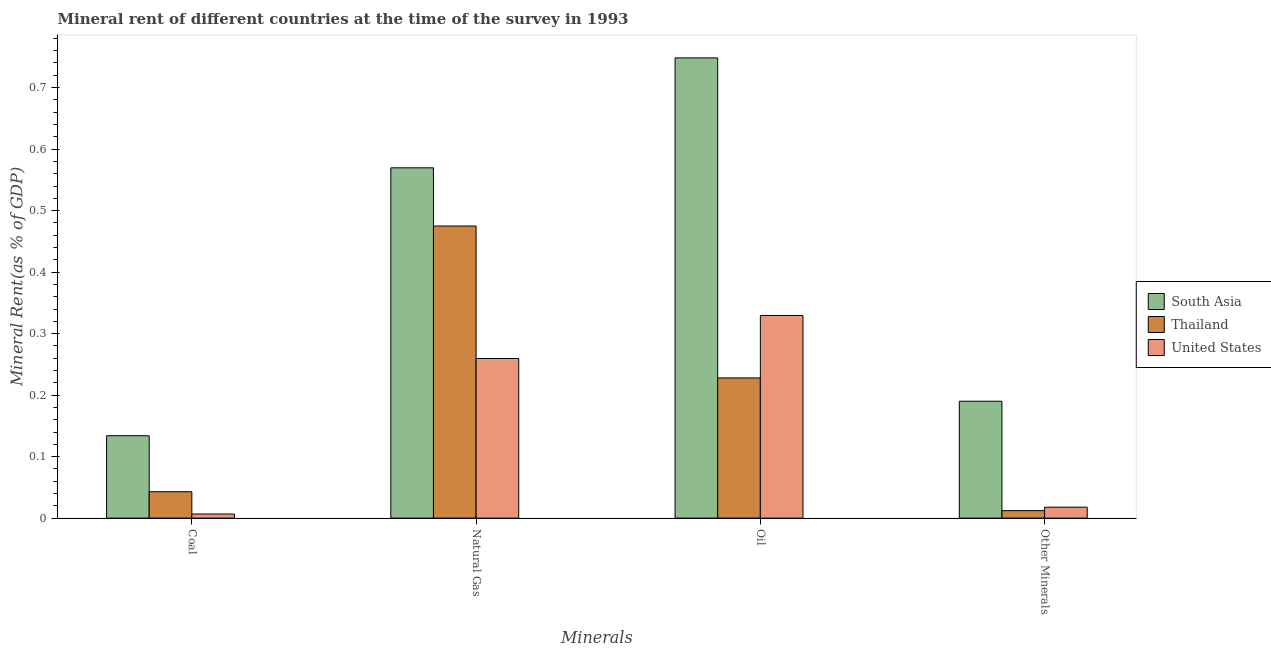How many groups of bars are there?
Your response must be concise. 4. Are the number of bars on each tick of the X-axis equal?
Your response must be concise. Yes. How many bars are there on the 2nd tick from the left?
Your answer should be very brief. 3. What is the label of the 2nd group of bars from the left?
Keep it short and to the point. Natural Gas. What is the coal rent in South Asia?
Offer a very short reply. 0.13. Across all countries, what is the maximum natural gas rent?
Your answer should be very brief. 0.57. Across all countries, what is the minimum oil rent?
Your response must be concise. 0.23. In which country was the coal rent maximum?
Provide a succinct answer. South Asia. In which country was the  rent of other minerals minimum?
Provide a succinct answer. Thailand. What is the total  rent of other minerals in the graph?
Ensure brevity in your answer.  0.22. What is the difference between the coal rent in United States and that in Thailand?
Provide a succinct answer. -0.04. What is the difference between the oil rent in United States and the natural gas rent in South Asia?
Your answer should be very brief. -0.24. What is the average oil rent per country?
Your answer should be compact. 0.44. What is the difference between the  rent of other minerals and natural gas rent in South Asia?
Provide a short and direct response. -0.38. In how many countries, is the natural gas rent greater than 0.1 %?
Provide a short and direct response. 3. What is the ratio of the coal rent in United States to that in Thailand?
Your answer should be very brief. 0.16. What is the difference between the highest and the second highest natural gas rent?
Your answer should be very brief. 0.09. What is the difference between the highest and the lowest  rent of other minerals?
Your answer should be compact. 0.18. Is the sum of the  rent of other minerals in Thailand and United States greater than the maximum oil rent across all countries?
Your response must be concise. No. Is it the case that in every country, the sum of the  rent of other minerals and coal rent is greater than the sum of natural gas rent and oil rent?
Give a very brief answer. No. What does the 1st bar from the left in Oil represents?
Your response must be concise. South Asia. What does the 2nd bar from the right in Natural Gas represents?
Offer a very short reply. Thailand. Is it the case that in every country, the sum of the coal rent and natural gas rent is greater than the oil rent?
Provide a succinct answer. No. How many bars are there?
Your answer should be compact. 12. Are all the bars in the graph horizontal?
Make the answer very short. No. What is the difference between two consecutive major ticks on the Y-axis?
Your response must be concise. 0.1. Are the values on the major ticks of Y-axis written in scientific E-notation?
Provide a succinct answer. No. Does the graph contain any zero values?
Provide a succinct answer. No. Where does the legend appear in the graph?
Your answer should be compact. Center right. What is the title of the graph?
Provide a succinct answer. Mineral rent of different countries at the time of the survey in 1993. What is the label or title of the X-axis?
Make the answer very short. Minerals. What is the label or title of the Y-axis?
Keep it short and to the point. Mineral Rent(as % of GDP). What is the Mineral Rent(as % of GDP) of South Asia in Coal?
Give a very brief answer. 0.13. What is the Mineral Rent(as % of GDP) in Thailand in Coal?
Ensure brevity in your answer.  0.04. What is the Mineral Rent(as % of GDP) in United States in Coal?
Offer a very short reply. 0.01. What is the Mineral Rent(as % of GDP) in South Asia in Natural Gas?
Your answer should be compact. 0.57. What is the Mineral Rent(as % of GDP) of Thailand in Natural Gas?
Your answer should be compact. 0.47. What is the Mineral Rent(as % of GDP) in United States in Natural Gas?
Make the answer very short. 0.26. What is the Mineral Rent(as % of GDP) of South Asia in Oil?
Keep it short and to the point. 0.75. What is the Mineral Rent(as % of GDP) in Thailand in Oil?
Offer a terse response. 0.23. What is the Mineral Rent(as % of GDP) of United States in Oil?
Provide a short and direct response. 0.33. What is the Mineral Rent(as % of GDP) in South Asia in Other Minerals?
Give a very brief answer. 0.19. What is the Mineral Rent(as % of GDP) of Thailand in Other Minerals?
Offer a very short reply. 0.01. What is the Mineral Rent(as % of GDP) in United States in Other Minerals?
Your answer should be compact. 0.02. Across all Minerals, what is the maximum Mineral Rent(as % of GDP) in South Asia?
Keep it short and to the point. 0.75. Across all Minerals, what is the maximum Mineral Rent(as % of GDP) in Thailand?
Give a very brief answer. 0.47. Across all Minerals, what is the maximum Mineral Rent(as % of GDP) of United States?
Your answer should be very brief. 0.33. Across all Minerals, what is the minimum Mineral Rent(as % of GDP) in South Asia?
Provide a short and direct response. 0.13. Across all Minerals, what is the minimum Mineral Rent(as % of GDP) of Thailand?
Your answer should be very brief. 0.01. Across all Minerals, what is the minimum Mineral Rent(as % of GDP) of United States?
Make the answer very short. 0.01. What is the total Mineral Rent(as % of GDP) of South Asia in the graph?
Offer a terse response. 1.64. What is the total Mineral Rent(as % of GDP) of Thailand in the graph?
Provide a succinct answer. 0.76. What is the total Mineral Rent(as % of GDP) in United States in the graph?
Make the answer very short. 0.61. What is the difference between the Mineral Rent(as % of GDP) in South Asia in Coal and that in Natural Gas?
Make the answer very short. -0.44. What is the difference between the Mineral Rent(as % of GDP) of Thailand in Coal and that in Natural Gas?
Provide a short and direct response. -0.43. What is the difference between the Mineral Rent(as % of GDP) in United States in Coal and that in Natural Gas?
Ensure brevity in your answer.  -0.25. What is the difference between the Mineral Rent(as % of GDP) of South Asia in Coal and that in Oil?
Keep it short and to the point. -0.61. What is the difference between the Mineral Rent(as % of GDP) in Thailand in Coal and that in Oil?
Provide a succinct answer. -0.18. What is the difference between the Mineral Rent(as % of GDP) of United States in Coal and that in Oil?
Your response must be concise. -0.32. What is the difference between the Mineral Rent(as % of GDP) in South Asia in Coal and that in Other Minerals?
Provide a short and direct response. -0.06. What is the difference between the Mineral Rent(as % of GDP) in Thailand in Coal and that in Other Minerals?
Ensure brevity in your answer.  0.03. What is the difference between the Mineral Rent(as % of GDP) of United States in Coal and that in Other Minerals?
Your answer should be very brief. -0.01. What is the difference between the Mineral Rent(as % of GDP) of South Asia in Natural Gas and that in Oil?
Provide a short and direct response. -0.18. What is the difference between the Mineral Rent(as % of GDP) of Thailand in Natural Gas and that in Oil?
Make the answer very short. 0.25. What is the difference between the Mineral Rent(as % of GDP) in United States in Natural Gas and that in Oil?
Your answer should be very brief. -0.07. What is the difference between the Mineral Rent(as % of GDP) of South Asia in Natural Gas and that in Other Minerals?
Your response must be concise. 0.38. What is the difference between the Mineral Rent(as % of GDP) of Thailand in Natural Gas and that in Other Minerals?
Your answer should be very brief. 0.46. What is the difference between the Mineral Rent(as % of GDP) in United States in Natural Gas and that in Other Minerals?
Provide a succinct answer. 0.24. What is the difference between the Mineral Rent(as % of GDP) in South Asia in Oil and that in Other Minerals?
Your answer should be very brief. 0.56. What is the difference between the Mineral Rent(as % of GDP) in Thailand in Oil and that in Other Minerals?
Keep it short and to the point. 0.22. What is the difference between the Mineral Rent(as % of GDP) in United States in Oil and that in Other Minerals?
Ensure brevity in your answer.  0.31. What is the difference between the Mineral Rent(as % of GDP) of South Asia in Coal and the Mineral Rent(as % of GDP) of Thailand in Natural Gas?
Provide a short and direct response. -0.34. What is the difference between the Mineral Rent(as % of GDP) of South Asia in Coal and the Mineral Rent(as % of GDP) of United States in Natural Gas?
Give a very brief answer. -0.13. What is the difference between the Mineral Rent(as % of GDP) in Thailand in Coal and the Mineral Rent(as % of GDP) in United States in Natural Gas?
Keep it short and to the point. -0.22. What is the difference between the Mineral Rent(as % of GDP) in South Asia in Coal and the Mineral Rent(as % of GDP) in Thailand in Oil?
Your answer should be very brief. -0.09. What is the difference between the Mineral Rent(as % of GDP) in South Asia in Coal and the Mineral Rent(as % of GDP) in United States in Oil?
Provide a short and direct response. -0.2. What is the difference between the Mineral Rent(as % of GDP) in Thailand in Coal and the Mineral Rent(as % of GDP) in United States in Oil?
Give a very brief answer. -0.29. What is the difference between the Mineral Rent(as % of GDP) of South Asia in Coal and the Mineral Rent(as % of GDP) of Thailand in Other Minerals?
Make the answer very short. 0.12. What is the difference between the Mineral Rent(as % of GDP) of South Asia in Coal and the Mineral Rent(as % of GDP) of United States in Other Minerals?
Provide a succinct answer. 0.12. What is the difference between the Mineral Rent(as % of GDP) of Thailand in Coal and the Mineral Rent(as % of GDP) of United States in Other Minerals?
Offer a terse response. 0.03. What is the difference between the Mineral Rent(as % of GDP) in South Asia in Natural Gas and the Mineral Rent(as % of GDP) in Thailand in Oil?
Your answer should be very brief. 0.34. What is the difference between the Mineral Rent(as % of GDP) in South Asia in Natural Gas and the Mineral Rent(as % of GDP) in United States in Oil?
Ensure brevity in your answer.  0.24. What is the difference between the Mineral Rent(as % of GDP) of Thailand in Natural Gas and the Mineral Rent(as % of GDP) of United States in Oil?
Your response must be concise. 0.15. What is the difference between the Mineral Rent(as % of GDP) in South Asia in Natural Gas and the Mineral Rent(as % of GDP) in Thailand in Other Minerals?
Offer a terse response. 0.56. What is the difference between the Mineral Rent(as % of GDP) of South Asia in Natural Gas and the Mineral Rent(as % of GDP) of United States in Other Minerals?
Your response must be concise. 0.55. What is the difference between the Mineral Rent(as % of GDP) of Thailand in Natural Gas and the Mineral Rent(as % of GDP) of United States in Other Minerals?
Make the answer very short. 0.46. What is the difference between the Mineral Rent(as % of GDP) of South Asia in Oil and the Mineral Rent(as % of GDP) of Thailand in Other Minerals?
Provide a succinct answer. 0.74. What is the difference between the Mineral Rent(as % of GDP) in South Asia in Oil and the Mineral Rent(as % of GDP) in United States in Other Minerals?
Your response must be concise. 0.73. What is the difference between the Mineral Rent(as % of GDP) of Thailand in Oil and the Mineral Rent(as % of GDP) of United States in Other Minerals?
Ensure brevity in your answer.  0.21. What is the average Mineral Rent(as % of GDP) of South Asia per Minerals?
Your answer should be very brief. 0.41. What is the average Mineral Rent(as % of GDP) in Thailand per Minerals?
Offer a very short reply. 0.19. What is the average Mineral Rent(as % of GDP) of United States per Minerals?
Provide a short and direct response. 0.15. What is the difference between the Mineral Rent(as % of GDP) of South Asia and Mineral Rent(as % of GDP) of Thailand in Coal?
Ensure brevity in your answer.  0.09. What is the difference between the Mineral Rent(as % of GDP) in South Asia and Mineral Rent(as % of GDP) in United States in Coal?
Give a very brief answer. 0.13. What is the difference between the Mineral Rent(as % of GDP) in Thailand and Mineral Rent(as % of GDP) in United States in Coal?
Ensure brevity in your answer.  0.04. What is the difference between the Mineral Rent(as % of GDP) in South Asia and Mineral Rent(as % of GDP) in Thailand in Natural Gas?
Offer a very short reply. 0.09. What is the difference between the Mineral Rent(as % of GDP) of South Asia and Mineral Rent(as % of GDP) of United States in Natural Gas?
Give a very brief answer. 0.31. What is the difference between the Mineral Rent(as % of GDP) in Thailand and Mineral Rent(as % of GDP) in United States in Natural Gas?
Provide a succinct answer. 0.22. What is the difference between the Mineral Rent(as % of GDP) of South Asia and Mineral Rent(as % of GDP) of Thailand in Oil?
Provide a short and direct response. 0.52. What is the difference between the Mineral Rent(as % of GDP) of South Asia and Mineral Rent(as % of GDP) of United States in Oil?
Ensure brevity in your answer.  0.42. What is the difference between the Mineral Rent(as % of GDP) in Thailand and Mineral Rent(as % of GDP) in United States in Oil?
Make the answer very short. -0.1. What is the difference between the Mineral Rent(as % of GDP) of South Asia and Mineral Rent(as % of GDP) of Thailand in Other Minerals?
Offer a terse response. 0.18. What is the difference between the Mineral Rent(as % of GDP) of South Asia and Mineral Rent(as % of GDP) of United States in Other Minerals?
Your response must be concise. 0.17. What is the difference between the Mineral Rent(as % of GDP) of Thailand and Mineral Rent(as % of GDP) of United States in Other Minerals?
Provide a succinct answer. -0.01. What is the ratio of the Mineral Rent(as % of GDP) in South Asia in Coal to that in Natural Gas?
Your answer should be very brief. 0.24. What is the ratio of the Mineral Rent(as % of GDP) of Thailand in Coal to that in Natural Gas?
Ensure brevity in your answer.  0.09. What is the ratio of the Mineral Rent(as % of GDP) of United States in Coal to that in Natural Gas?
Offer a terse response. 0.03. What is the ratio of the Mineral Rent(as % of GDP) of South Asia in Coal to that in Oil?
Offer a very short reply. 0.18. What is the ratio of the Mineral Rent(as % of GDP) of Thailand in Coal to that in Oil?
Make the answer very short. 0.19. What is the ratio of the Mineral Rent(as % of GDP) of United States in Coal to that in Oil?
Give a very brief answer. 0.02. What is the ratio of the Mineral Rent(as % of GDP) in South Asia in Coal to that in Other Minerals?
Provide a short and direct response. 0.71. What is the ratio of the Mineral Rent(as % of GDP) in Thailand in Coal to that in Other Minerals?
Your response must be concise. 3.52. What is the ratio of the Mineral Rent(as % of GDP) of United States in Coal to that in Other Minerals?
Your response must be concise. 0.38. What is the ratio of the Mineral Rent(as % of GDP) of South Asia in Natural Gas to that in Oil?
Your answer should be compact. 0.76. What is the ratio of the Mineral Rent(as % of GDP) in Thailand in Natural Gas to that in Oil?
Your answer should be compact. 2.08. What is the ratio of the Mineral Rent(as % of GDP) in United States in Natural Gas to that in Oil?
Your answer should be very brief. 0.79. What is the ratio of the Mineral Rent(as % of GDP) in South Asia in Natural Gas to that in Other Minerals?
Your response must be concise. 3. What is the ratio of the Mineral Rent(as % of GDP) of Thailand in Natural Gas to that in Other Minerals?
Your response must be concise. 38.99. What is the ratio of the Mineral Rent(as % of GDP) in United States in Natural Gas to that in Other Minerals?
Offer a very short reply. 14.59. What is the ratio of the Mineral Rent(as % of GDP) of South Asia in Oil to that in Other Minerals?
Offer a terse response. 3.94. What is the ratio of the Mineral Rent(as % of GDP) in Thailand in Oil to that in Other Minerals?
Offer a terse response. 18.71. What is the ratio of the Mineral Rent(as % of GDP) of United States in Oil to that in Other Minerals?
Ensure brevity in your answer.  18.52. What is the difference between the highest and the second highest Mineral Rent(as % of GDP) of South Asia?
Ensure brevity in your answer.  0.18. What is the difference between the highest and the second highest Mineral Rent(as % of GDP) in Thailand?
Offer a very short reply. 0.25. What is the difference between the highest and the second highest Mineral Rent(as % of GDP) in United States?
Provide a succinct answer. 0.07. What is the difference between the highest and the lowest Mineral Rent(as % of GDP) of South Asia?
Your answer should be very brief. 0.61. What is the difference between the highest and the lowest Mineral Rent(as % of GDP) of Thailand?
Give a very brief answer. 0.46. What is the difference between the highest and the lowest Mineral Rent(as % of GDP) in United States?
Your answer should be compact. 0.32. 